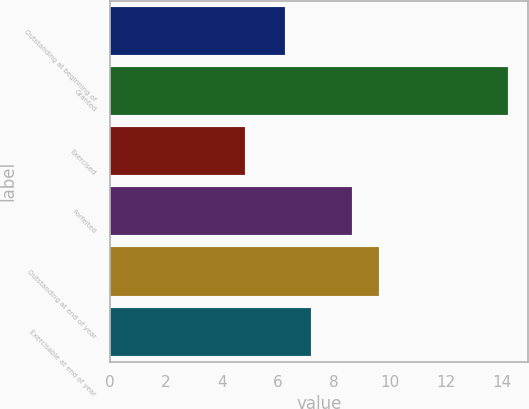Convert chart to OTSL. <chart><loc_0><loc_0><loc_500><loc_500><bar_chart><fcel>Outstanding at beginning of<fcel>Granted<fcel>Exercised<fcel>Forfeited<fcel>Outstanding at end of year<fcel>Exercisable at end of year<nl><fcel>6.25<fcel>14.22<fcel>4.83<fcel>8.65<fcel>9.59<fcel>7.19<nl></chart> 